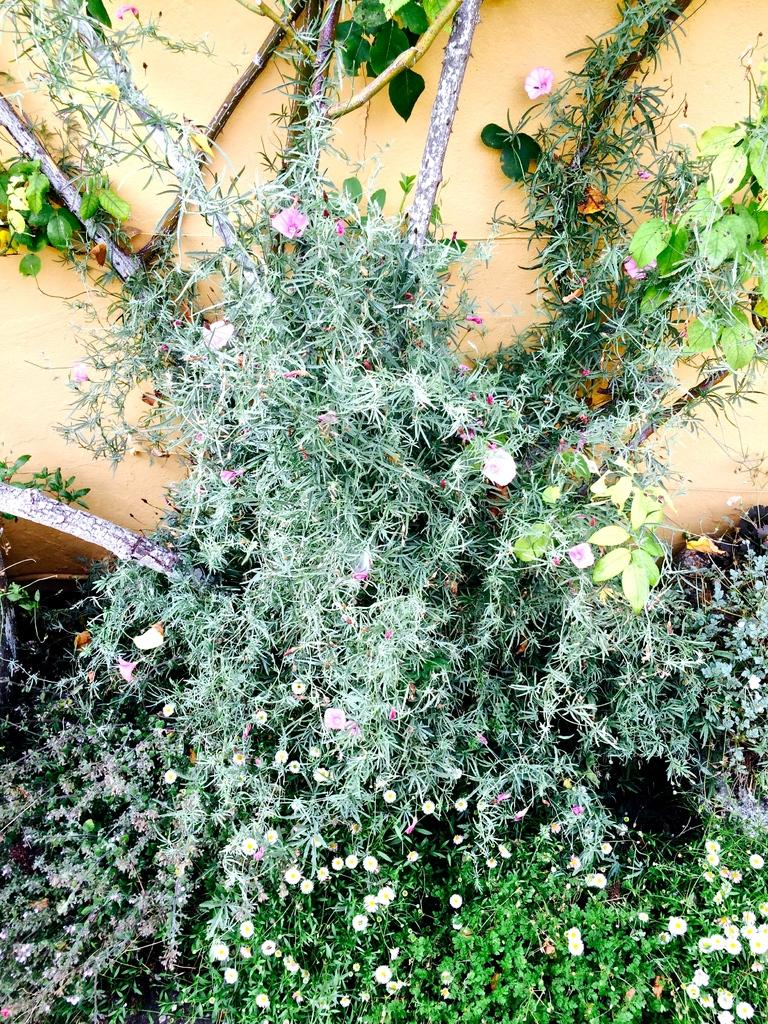What type of living organisms can be seen in the image? Plants can be seen in the image. What features are present on the plants? The plants have flowers, leaves, and thorns. How many bubbles are floating around the plants in the image? There are no bubbles present in the image; it features plants with flowers, leaves, and thorns. 